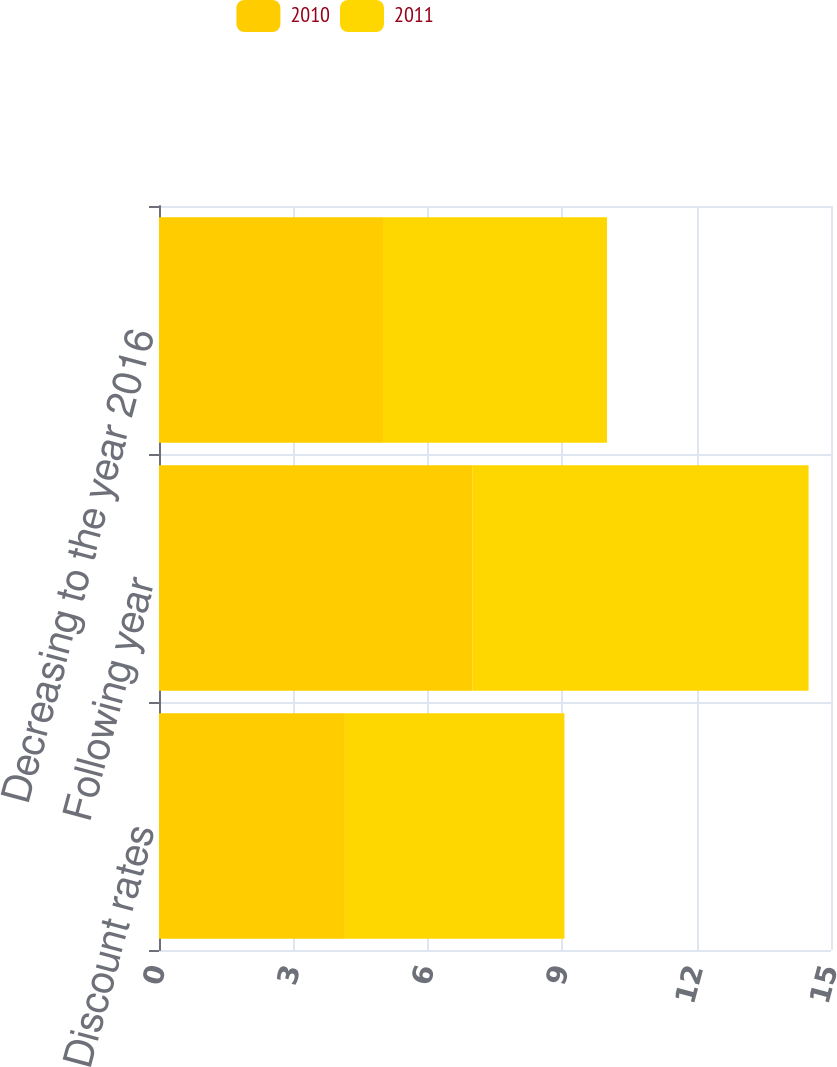Convert chart to OTSL. <chart><loc_0><loc_0><loc_500><loc_500><stacked_bar_chart><ecel><fcel>Discount rates<fcel>Following year<fcel>Decreasing to the year 2016<nl><fcel>2010<fcel>4.15<fcel>7<fcel>5<nl><fcel>2011<fcel>4.9<fcel>7.5<fcel>5<nl></chart> 